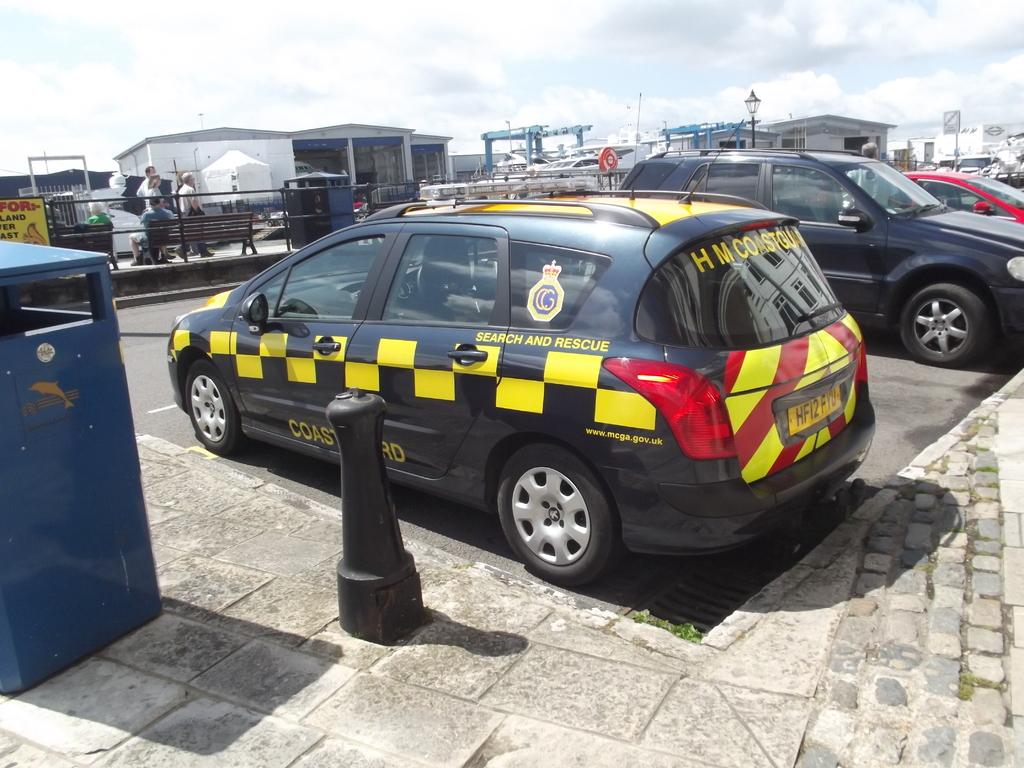What type of vehicles can be seen on the right side of the image? There are cars on the right side of the image. What else can be seen in the background of the image besides the cars? There are persons and sheds visible in the background of the image. What is visible at the top of the image? The sky is visible at the top of the image. How does the light trick the persons in the image? There is no mention of light or trickery in the image, so it cannot be determined how light might affect the persons in the image. 